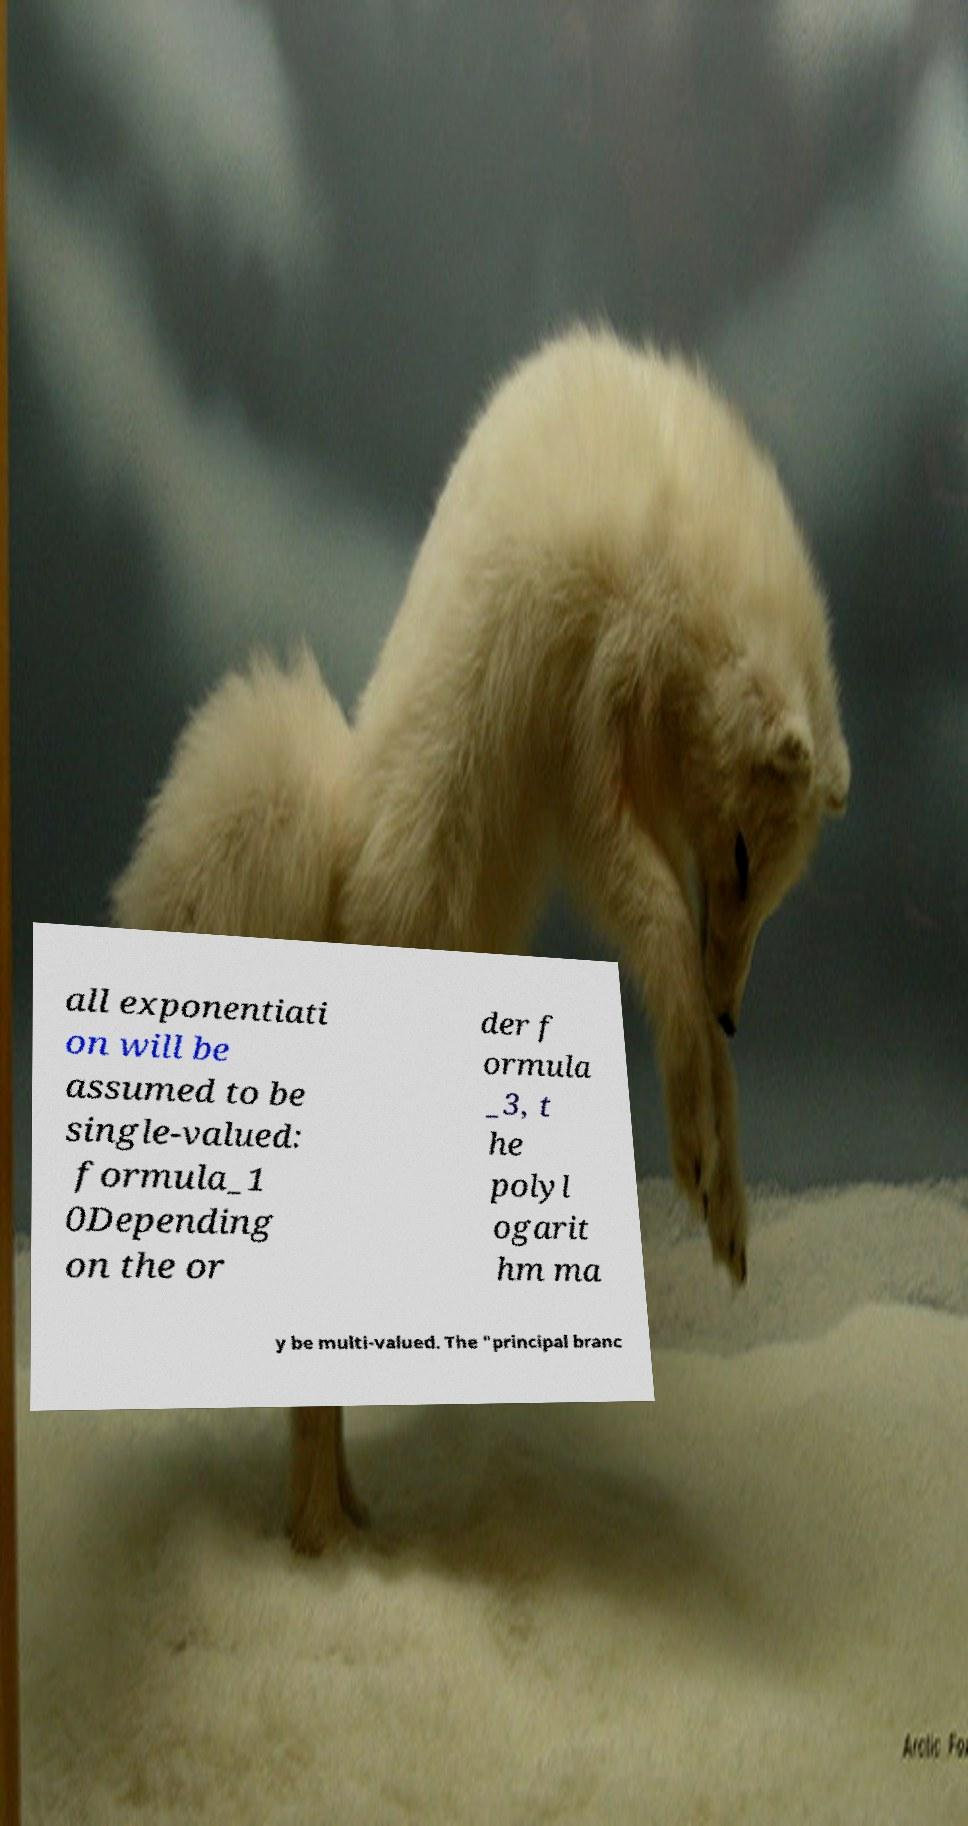Please read and relay the text visible in this image. What does it say? all exponentiati on will be assumed to be single-valued: formula_1 0Depending on the or der f ormula _3, t he polyl ogarit hm ma y be multi-valued. The "principal branc 